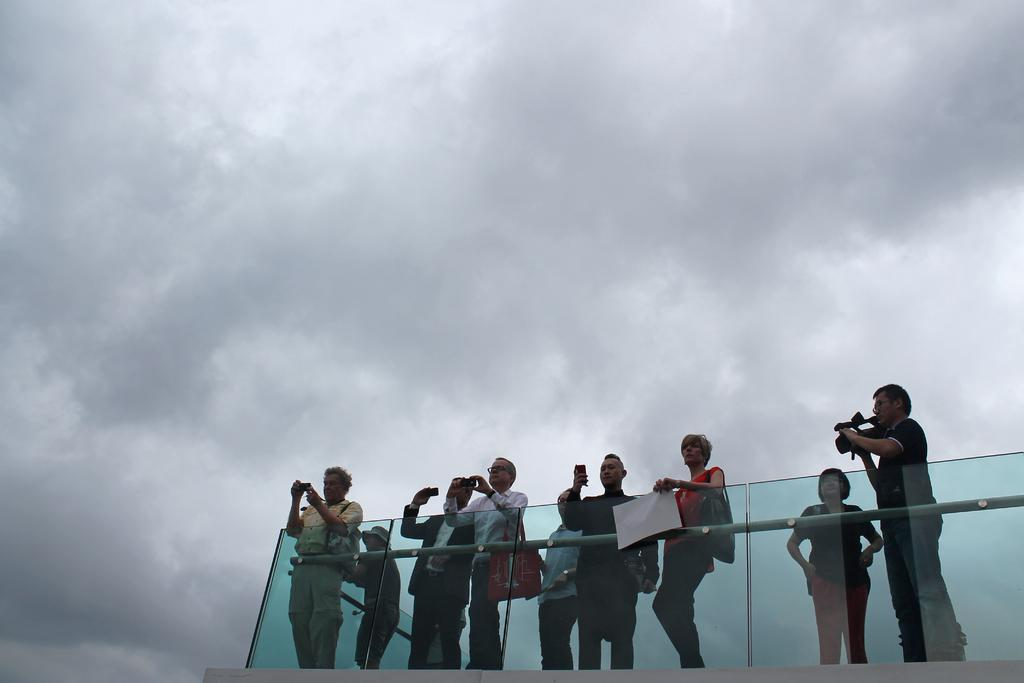What is happening in the image? There are people standing in the image. What can be seen in the sky in the background of the image? There are clouds visible in the sky in the background of the image. What type of stitch is being used by the people in the image? There is no stitching or sewing activity present in the image; the people are simply standing. 